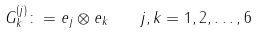Convert formula to latex. <formula><loc_0><loc_0><loc_500><loc_500>G ^ { ( j ) } _ { k } \colon = e _ { j } \otimes e _ { k } \quad j , k = 1 , 2 , \dots , 6</formula> 